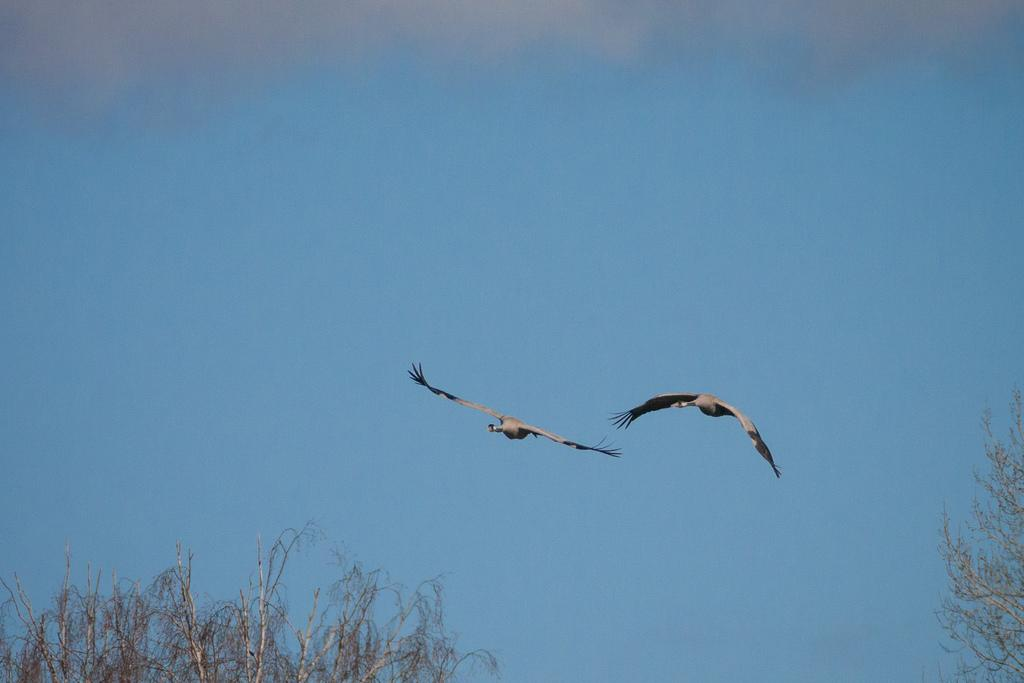What animals can be seen in the image? There are two birds in the air in the image. What type of vegetation is present in the image? There are trees in the image. What can be seen in the background of the image? The sky is visible in the background of the image. What type of fruit can be seen hanging from the trees in the image? There is no fruit visible in the image, and the type of trees is not specified, so it cannot be determined what type of fruit might be hanging from them. 